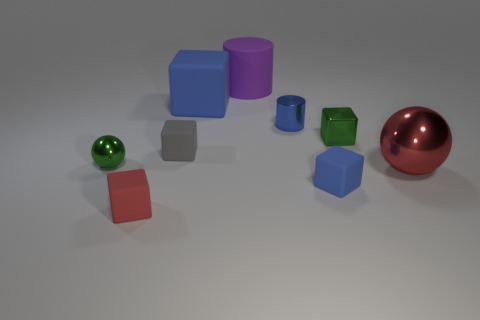The tiny matte thing that is the same color as the large matte cube is what shape?
Your answer should be compact. Cube. What color is the matte cylinder that is the same size as the red metal sphere?
Give a very brief answer. Purple. There is a shiny sphere that is to the right of the blue object behind the small blue metallic cylinder; what is its size?
Your answer should be very brief. Large. What is the size of the shiny ball that is the same color as the tiny metallic block?
Offer a terse response. Small. How many other objects are there of the same size as the red ball?
Offer a very short reply. 2. What number of gray matte things are there?
Your answer should be compact. 1. Is the size of the gray rubber cube the same as the blue metal cylinder?
Your response must be concise. Yes. What number of other objects are there of the same shape as the tiny red rubber thing?
Ensure brevity in your answer.  4. There is a red thing to the right of the blue block left of the tiny blue rubber object; what is it made of?
Keep it short and to the point. Metal. There is a purple matte object; are there any cubes on the left side of it?
Your answer should be compact. Yes. 